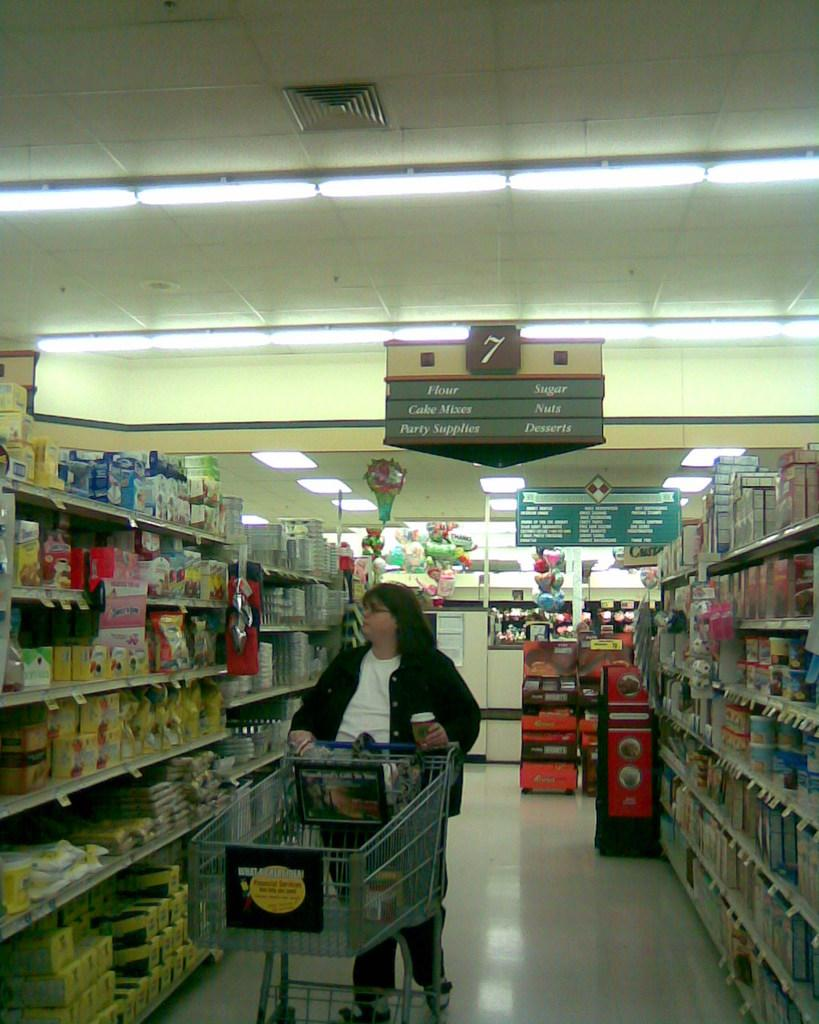<image>
Render a clear and concise summary of the photo. Aisle 7 is where you will find nuts and sugar in this store 